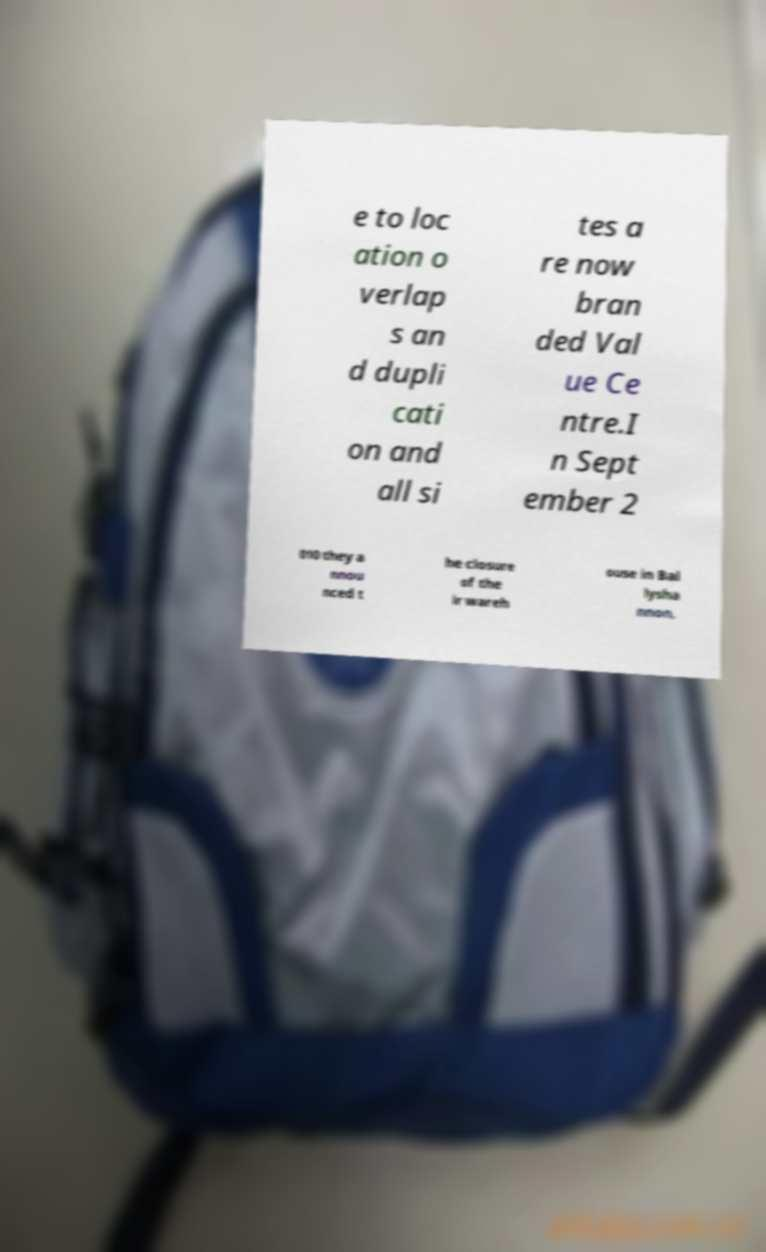For documentation purposes, I need the text within this image transcribed. Could you provide that? e to loc ation o verlap s an d dupli cati on and all si tes a re now bran ded Val ue Ce ntre.I n Sept ember 2 010 they a nnou nced t he closure of the ir wareh ouse in Bal lysha nnon, 